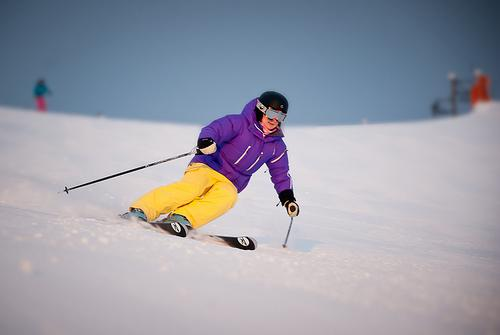Question: what color is the jacket?
Choices:
A. Red.
B. Yellow.
C. Purple.
D. Brown.
Answer with the letter. Answer: C Question: how is the skier keeping balance?
Choices:
A. By keeping his arms out.
B. By skiing slowly.
C. With two ski poles.
D. By keeping his feet on the ground.
Answer with the letter. Answer: C Question: what color are the skiers pants?
Choices:
A. White.
B. Black.
C. Yellow.
D. Green.
Answer with the letter. Answer: C Question: why is the skier leaning?
Choices:
A. To stop in the snow.
B. To go faster.
C. To slow down.
D. To turn in the snow.
Answer with the letter. Answer: D Question: what color is the snow?
Choices:
A. Gray.
B. Yellow.
C. Brown.
D. White.
Answer with the letter. Answer: D 